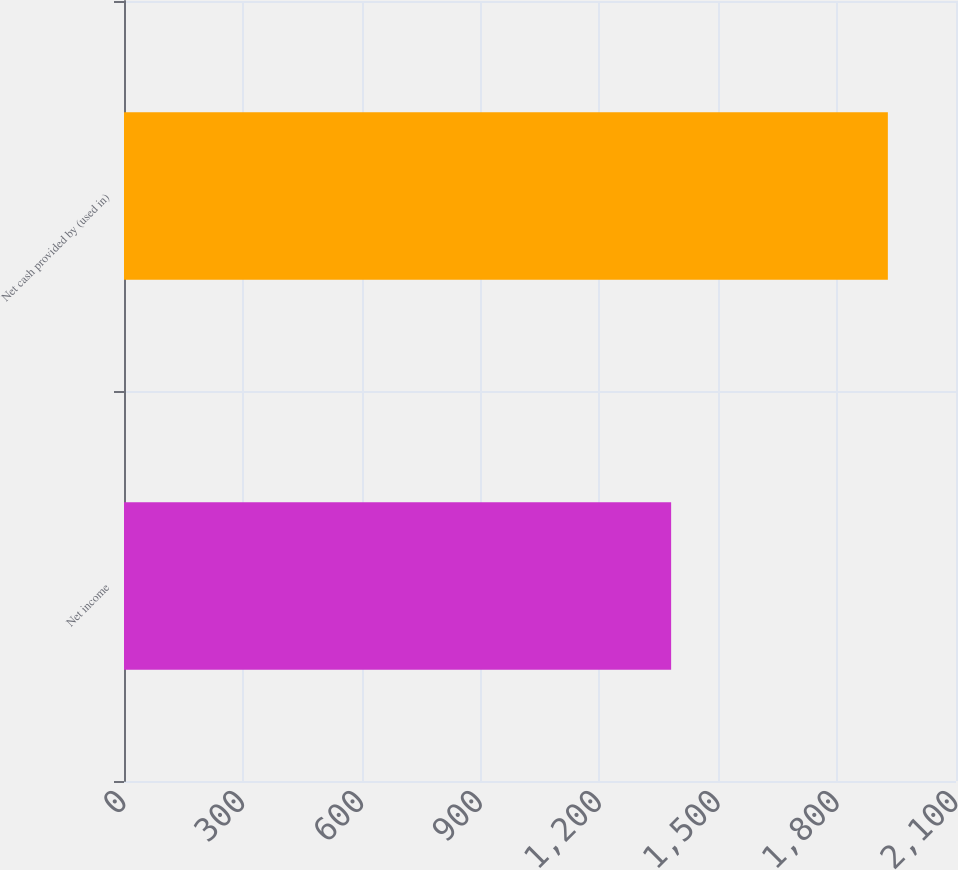<chart> <loc_0><loc_0><loc_500><loc_500><bar_chart><fcel>Net income<fcel>Net cash provided by (used in)<nl><fcel>1381<fcel>1928<nl></chart> 